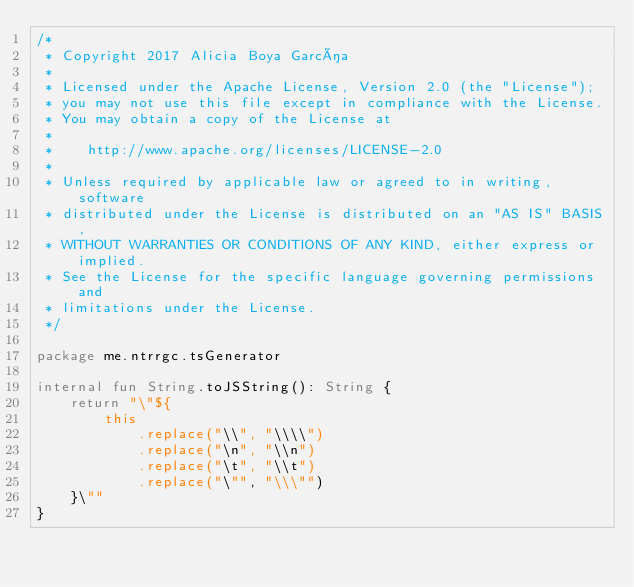Convert code to text. <code><loc_0><loc_0><loc_500><loc_500><_Kotlin_>/*
 * Copyright 2017 Alicia Boya García
 *
 * Licensed under the Apache License, Version 2.0 (the "License");
 * you may not use this file except in compliance with the License.
 * You may obtain a copy of the License at
 *
 *    http://www.apache.org/licenses/LICENSE-2.0
 *
 * Unless required by applicable law or agreed to in writing, software
 * distributed under the License is distributed on an "AS IS" BASIS,
 * WITHOUT WARRANTIES OR CONDITIONS OF ANY KIND, either express or implied.
 * See the License for the specific language governing permissions and
 * limitations under the License.
 */

package me.ntrrgc.tsGenerator

internal fun String.toJSString(): String {
    return "\"${
        this
            .replace("\\", "\\\\")
            .replace("\n", "\\n")
            .replace("\t", "\\t")
            .replace("\"", "\\\"")
    }\""
}
</code> 